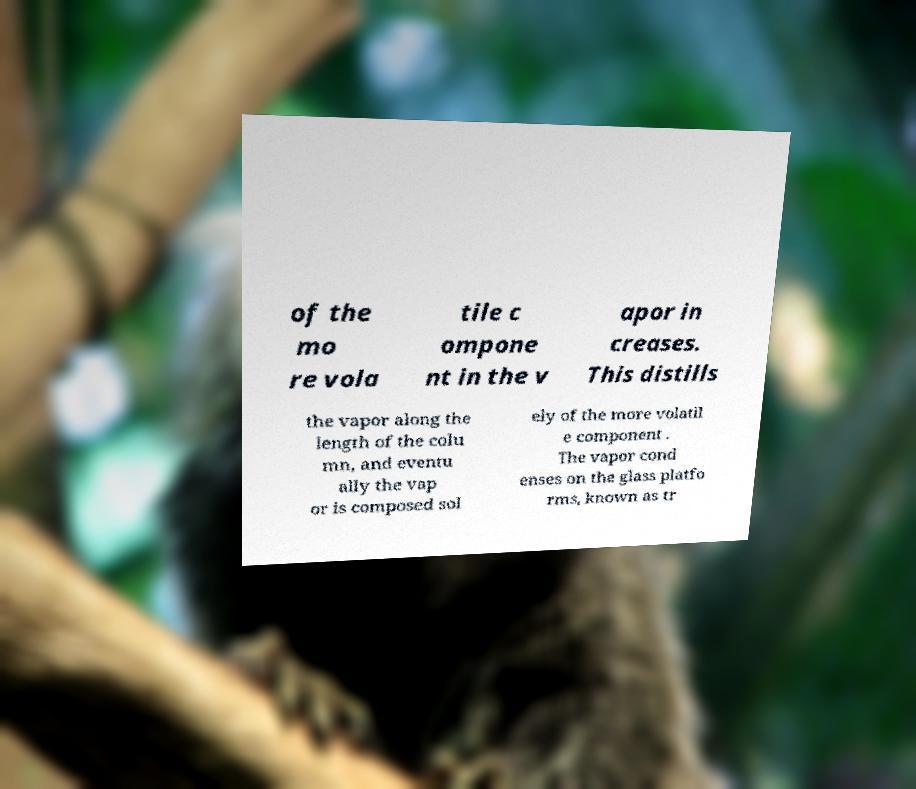I need the written content from this picture converted into text. Can you do that? of the mo re vola tile c ompone nt in the v apor in creases. This distills the vapor along the length of the colu mn, and eventu ally the vap or is composed sol ely of the more volatil e component . The vapor cond enses on the glass platfo rms, known as tr 